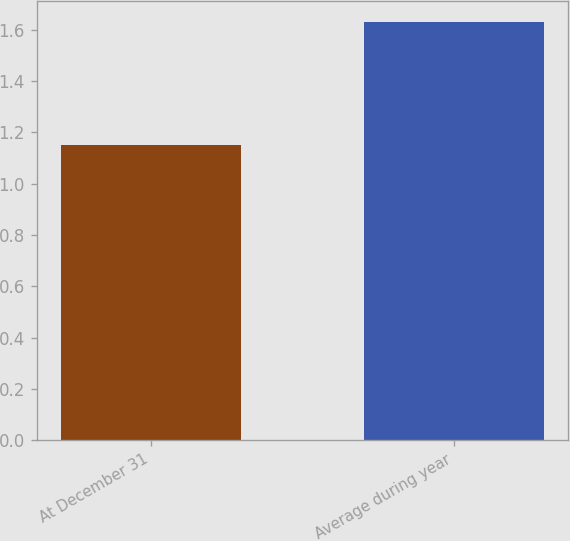Convert chart to OTSL. <chart><loc_0><loc_0><loc_500><loc_500><bar_chart><fcel>At December 31<fcel>Average during year<nl><fcel>1.15<fcel>1.63<nl></chart> 